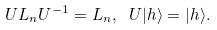Convert formula to latex. <formula><loc_0><loc_0><loc_500><loc_500>U L _ { n } U ^ { - 1 } = L _ { n } , \ U | h \rangle = | h \rangle .</formula> 